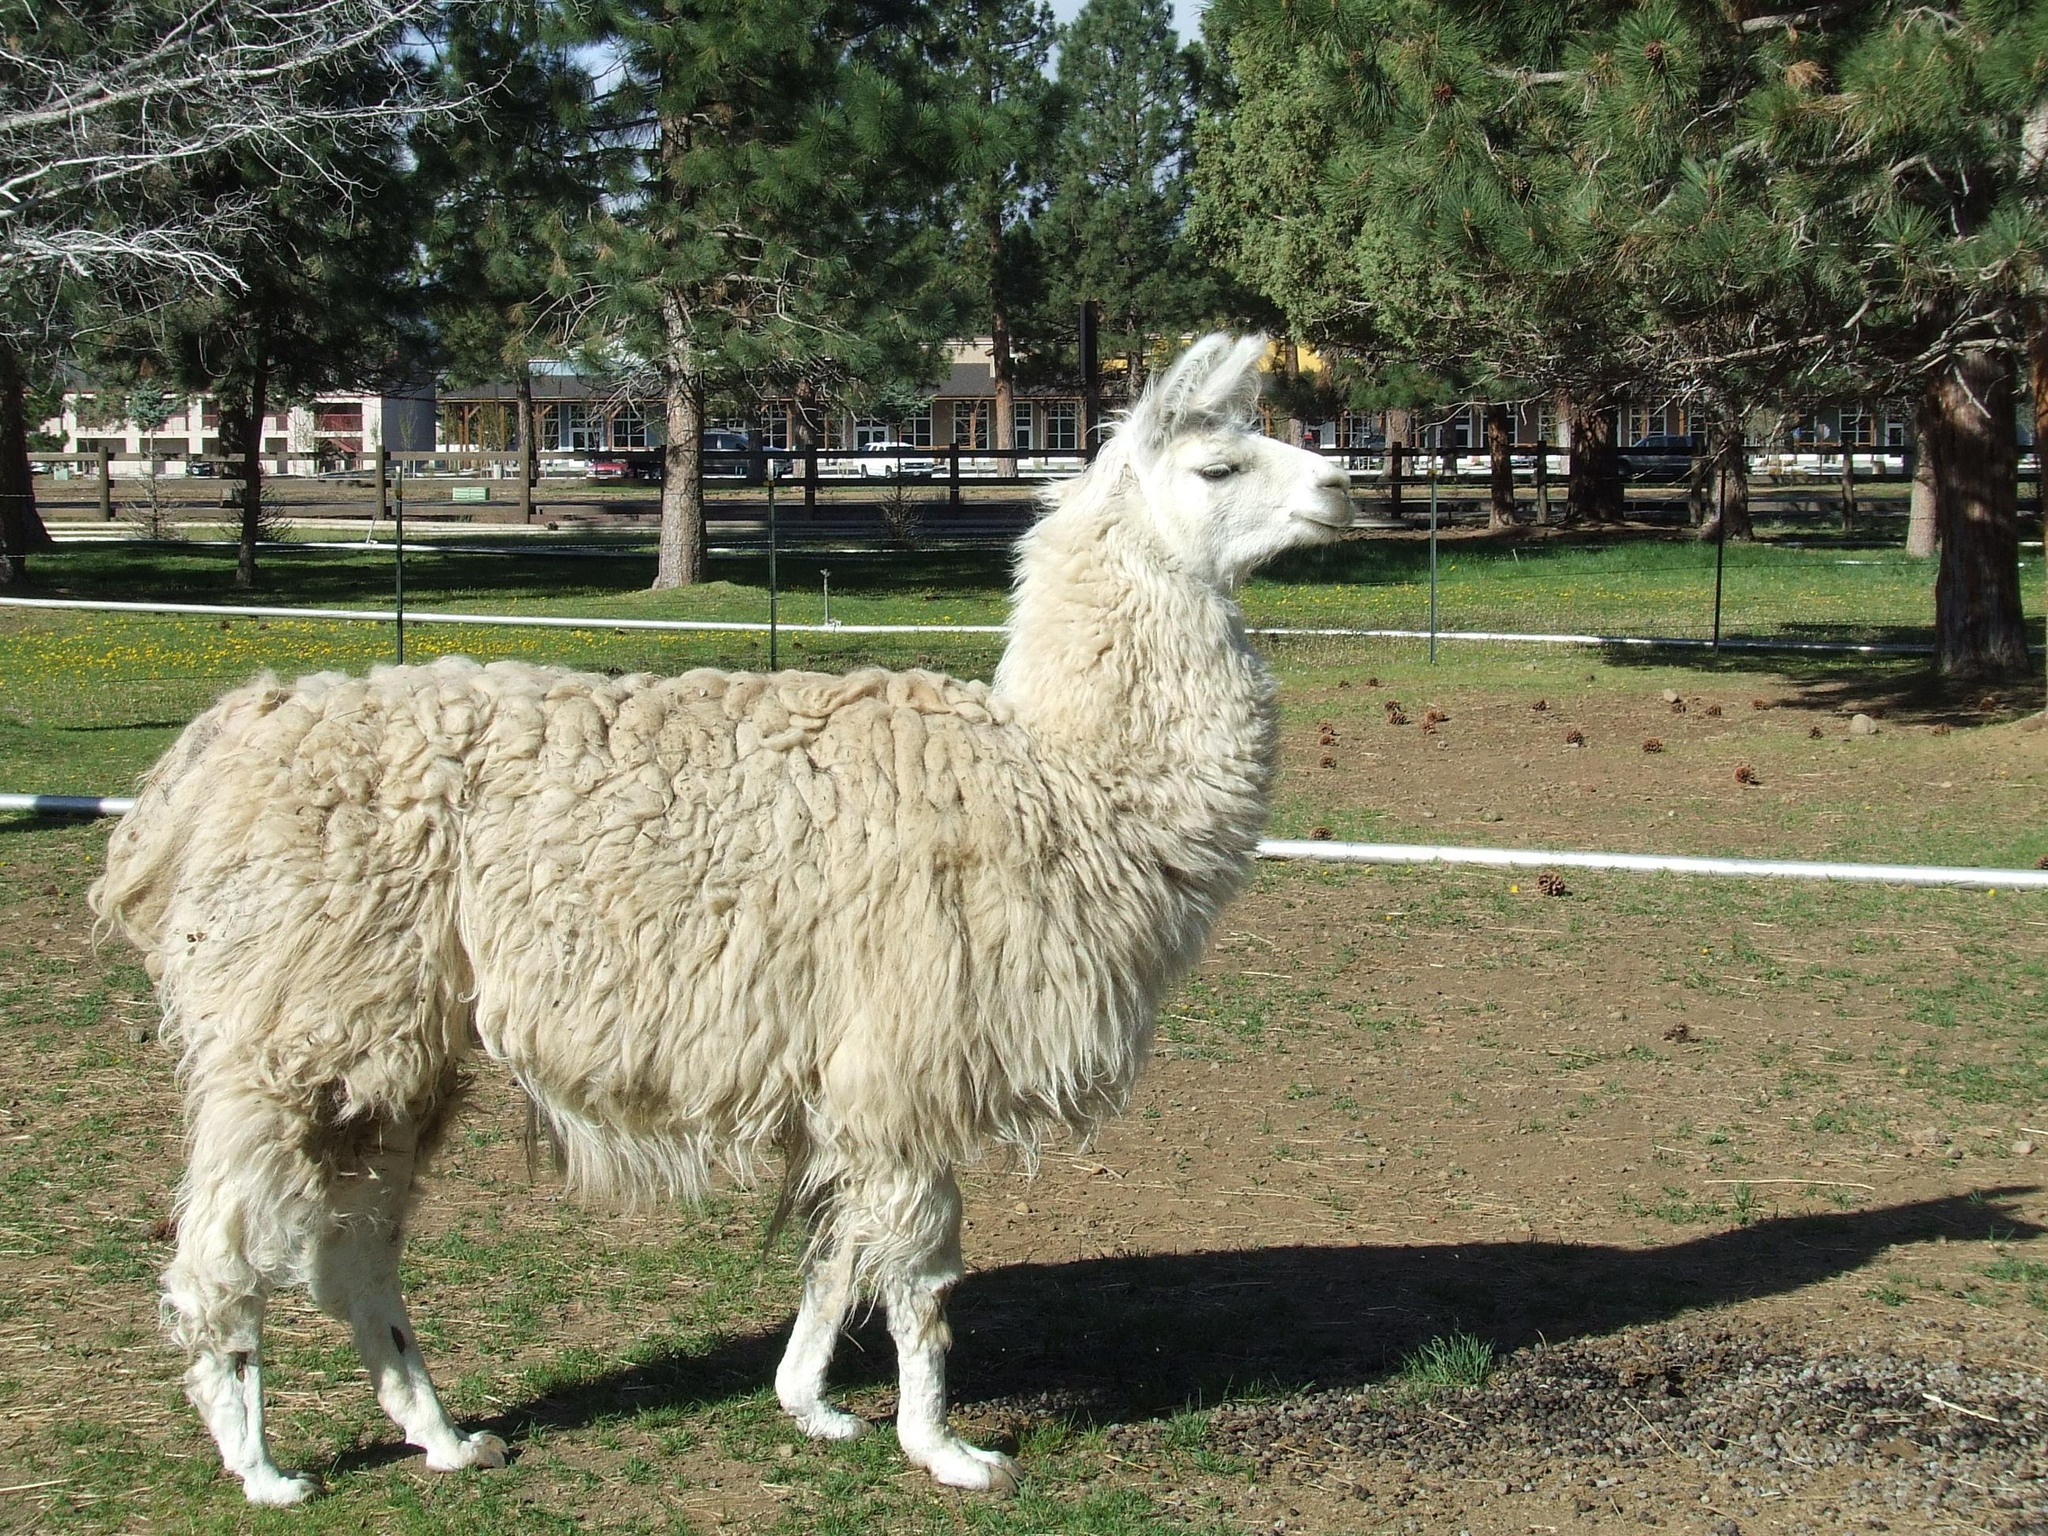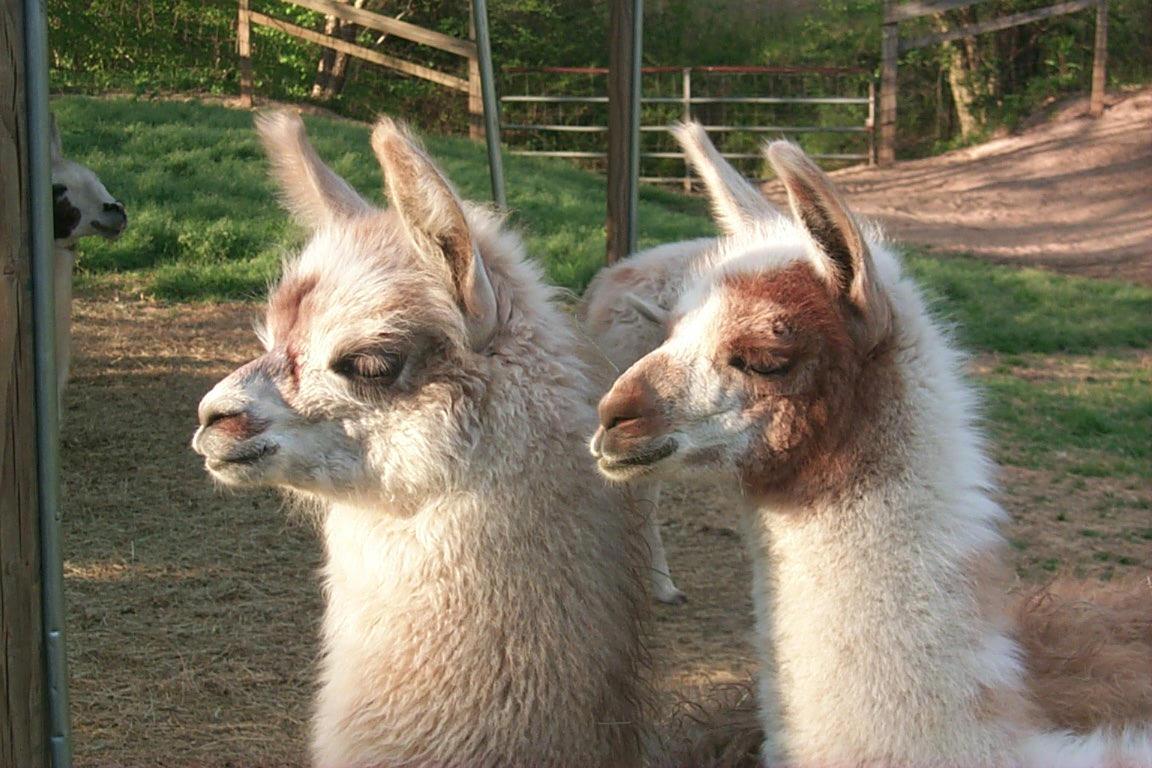The first image is the image on the left, the second image is the image on the right. Given the left and right images, does the statement "IN at least one image there are six llamas standing on grass." hold true? Answer yes or no. No. The first image is the image on the left, the second image is the image on the right. Examine the images to the left and right. Is the description "An image shows just one llama, which is standing in profile on dry ground, with its face and body turned the same way." accurate? Answer yes or no. Yes. 